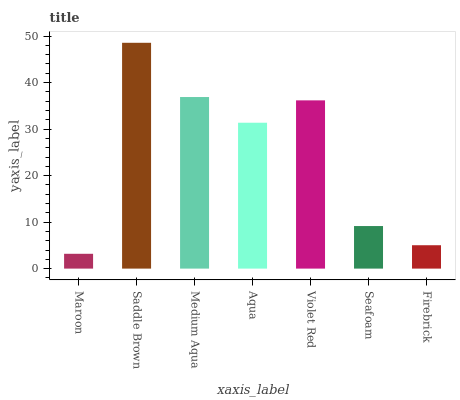Is Maroon the minimum?
Answer yes or no. Yes. Is Saddle Brown the maximum?
Answer yes or no. Yes. Is Medium Aqua the minimum?
Answer yes or no. No. Is Medium Aqua the maximum?
Answer yes or no. No. Is Saddle Brown greater than Medium Aqua?
Answer yes or no. Yes. Is Medium Aqua less than Saddle Brown?
Answer yes or no. Yes. Is Medium Aqua greater than Saddle Brown?
Answer yes or no. No. Is Saddle Brown less than Medium Aqua?
Answer yes or no. No. Is Aqua the high median?
Answer yes or no. Yes. Is Aqua the low median?
Answer yes or no. Yes. Is Seafoam the high median?
Answer yes or no. No. Is Violet Red the low median?
Answer yes or no. No. 